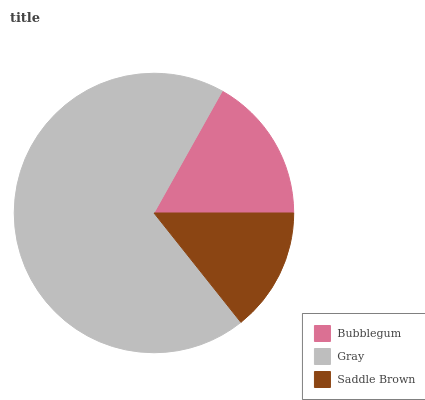Is Saddle Brown the minimum?
Answer yes or no. Yes. Is Gray the maximum?
Answer yes or no. Yes. Is Gray the minimum?
Answer yes or no. No. Is Saddle Brown the maximum?
Answer yes or no. No. Is Gray greater than Saddle Brown?
Answer yes or no. Yes. Is Saddle Brown less than Gray?
Answer yes or no. Yes. Is Saddle Brown greater than Gray?
Answer yes or no. No. Is Gray less than Saddle Brown?
Answer yes or no. No. Is Bubblegum the high median?
Answer yes or no. Yes. Is Bubblegum the low median?
Answer yes or no. Yes. Is Saddle Brown the high median?
Answer yes or no. No. Is Saddle Brown the low median?
Answer yes or no. No. 